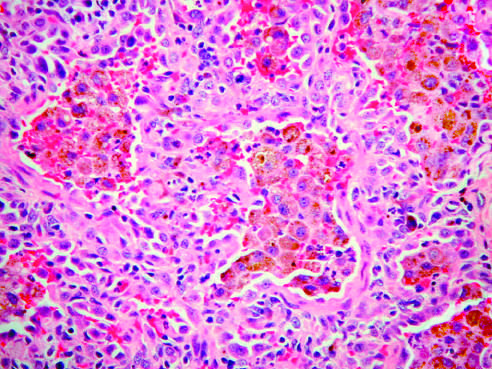what demonstrates large numbers of intraalveolar hemosiderin-laden macrophages on a background of thickened fibrous septa?
Answer the question using a single word or phrase. Lung biopsy specimen 